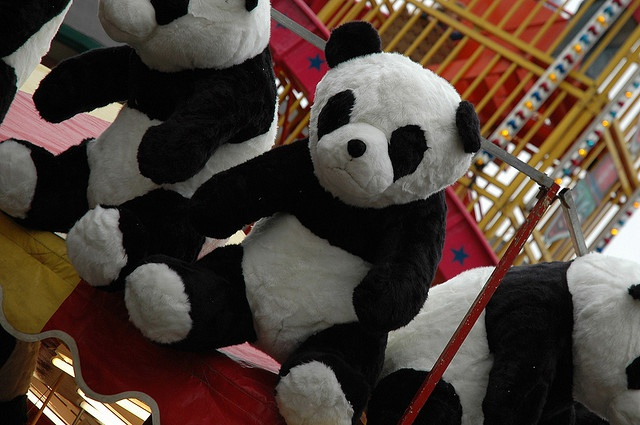Describe the objects in this image and their specific colors. I can see teddy bear in black, gray, darkgray, and lightgray tones, teddy bear in black, gray, and darkgray tones, teddy bear in black, gray, darkgray, and lightgray tones, and teddy bear in black, darkgray, and gray tones in this image. 